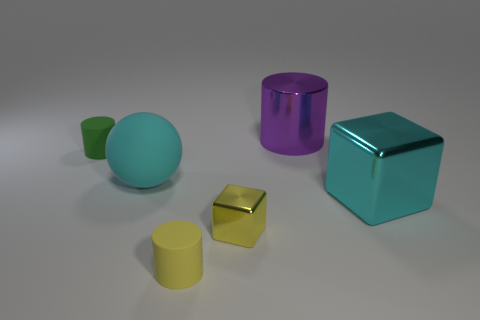Add 3 cylinders. How many objects exist? 9 Subtract all tiny yellow cylinders. How many cylinders are left? 2 Subtract all yellow cylinders. How many cyan cubes are left? 1 Subtract all green cylinders. How many cylinders are left? 2 Subtract all cubes. How many objects are left? 4 Subtract all tiny brown shiny cylinders. Subtract all yellow rubber cylinders. How many objects are left? 5 Add 5 tiny yellow shiny blocks. How many tiny yellow shiny blocks are left? 6 Add 3 tiny green shiny cylinders. How many tiny green shiny cylinders exist? 3 Subtract 0 brown blocks. How many objects are left? 6 Subtract 1 balls. How many balls are left? 0 